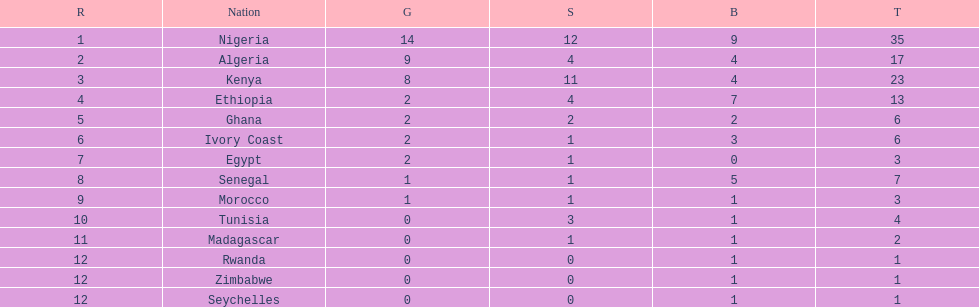The nation above algeria Nigeria. 